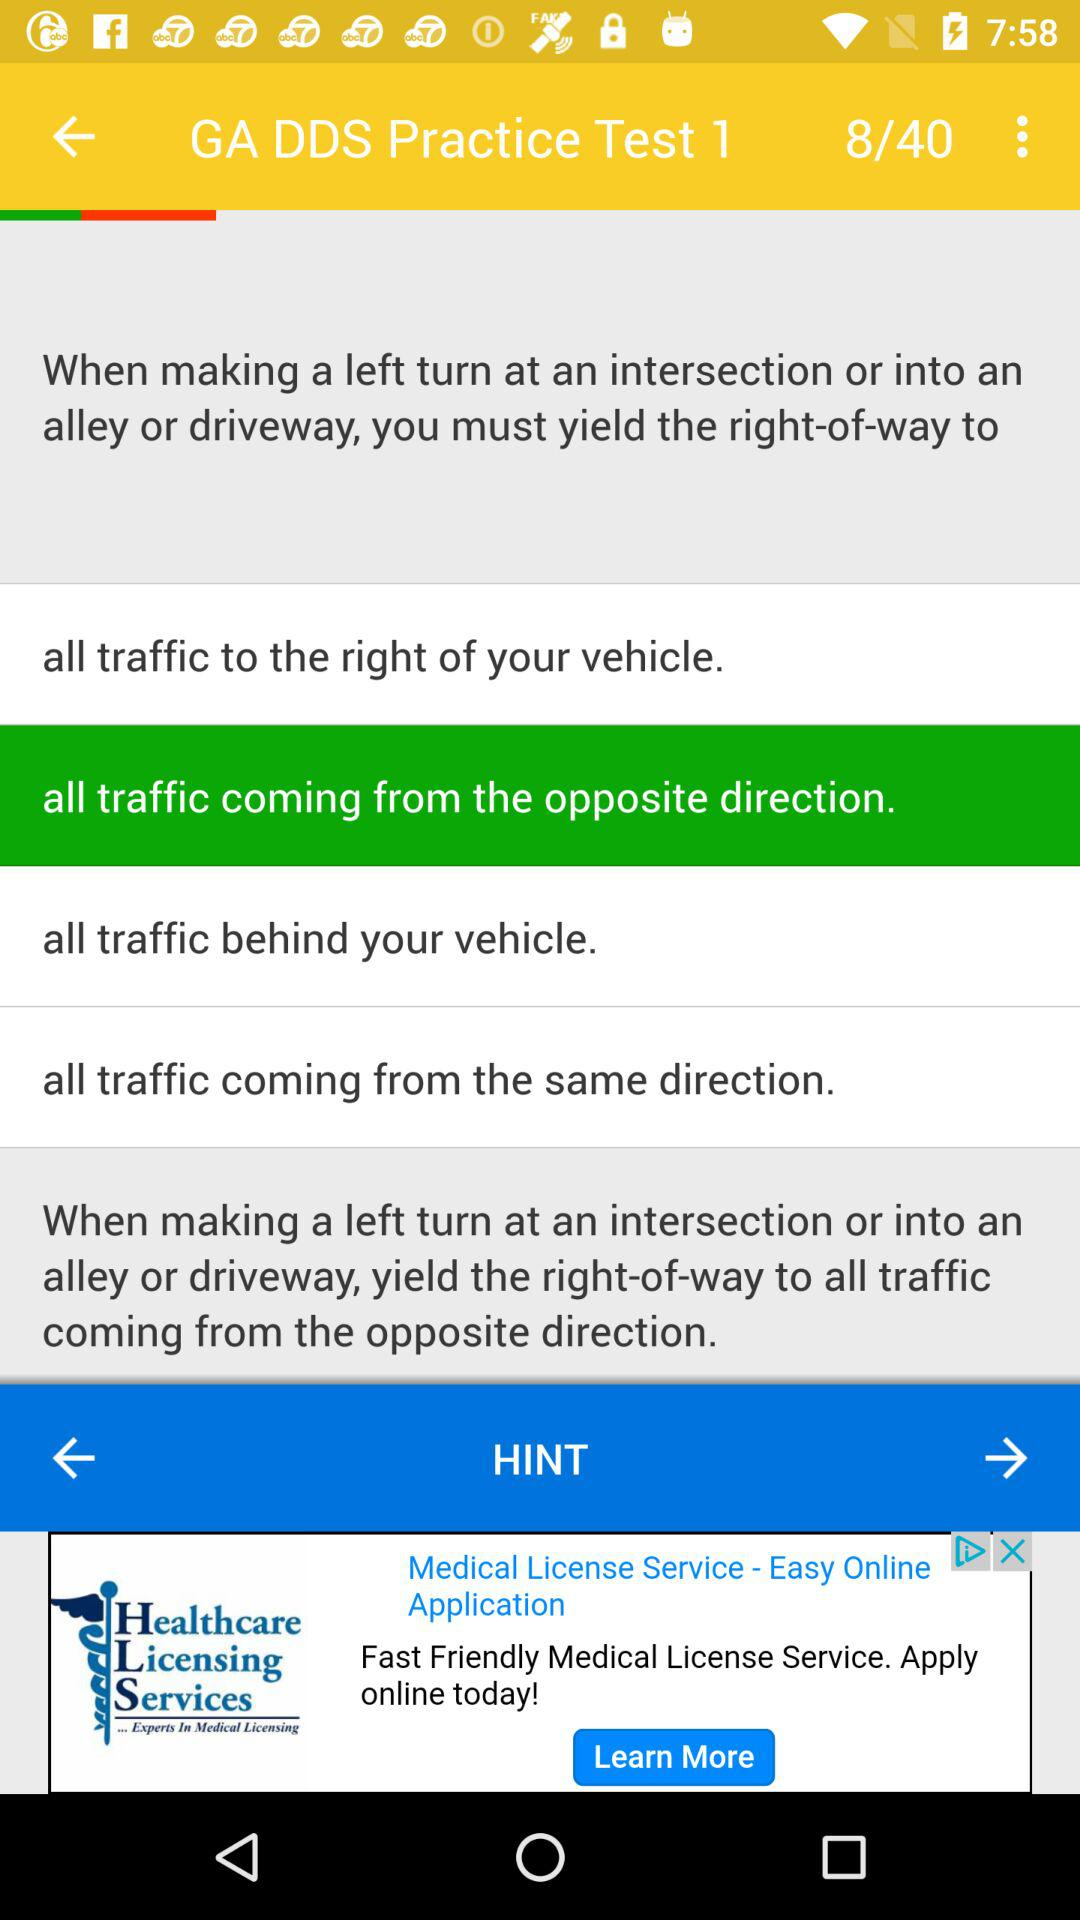Which option is currently selected? The currently selected option is "all traffic coming from the opposite direction". 